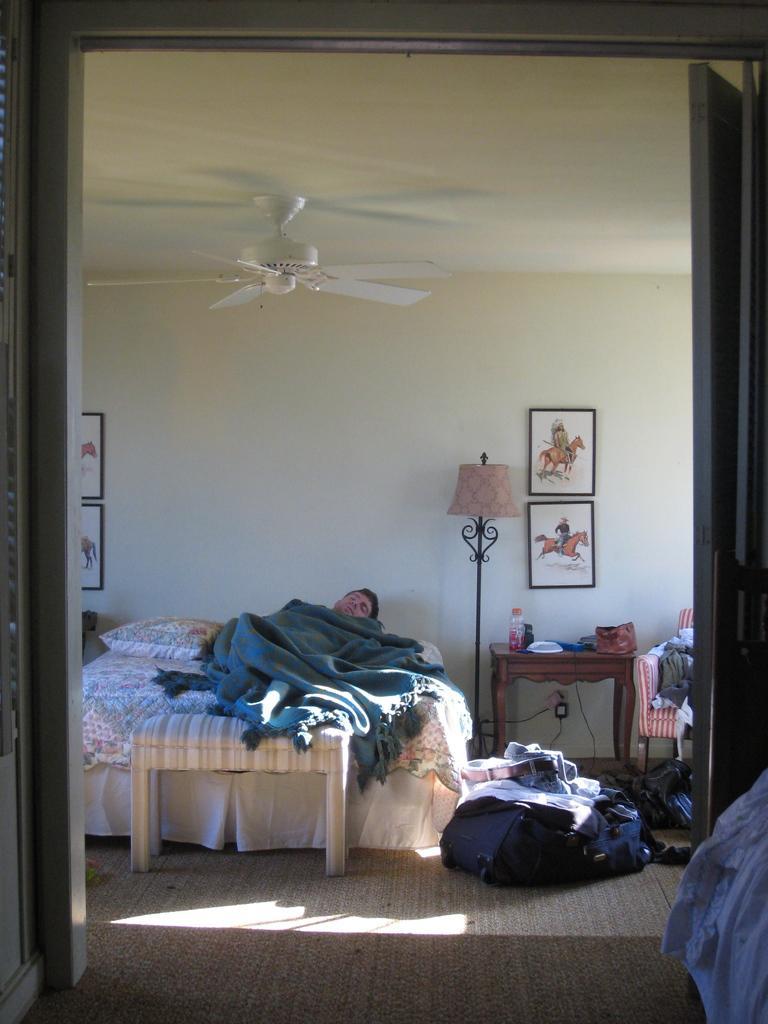Describe this image in one or two sentences. Under the blanket there is a man who is laying on a bed. Besides the bed there is a lamp. On the table there is a bottle, plate and box. On the ride there is a chair on which having a some cloth. On the background there is a wall and some photo frames which shows that a man and a horse. On the right corner there is a window. Here it's a fan. On the there is a blue bag and a towel. 